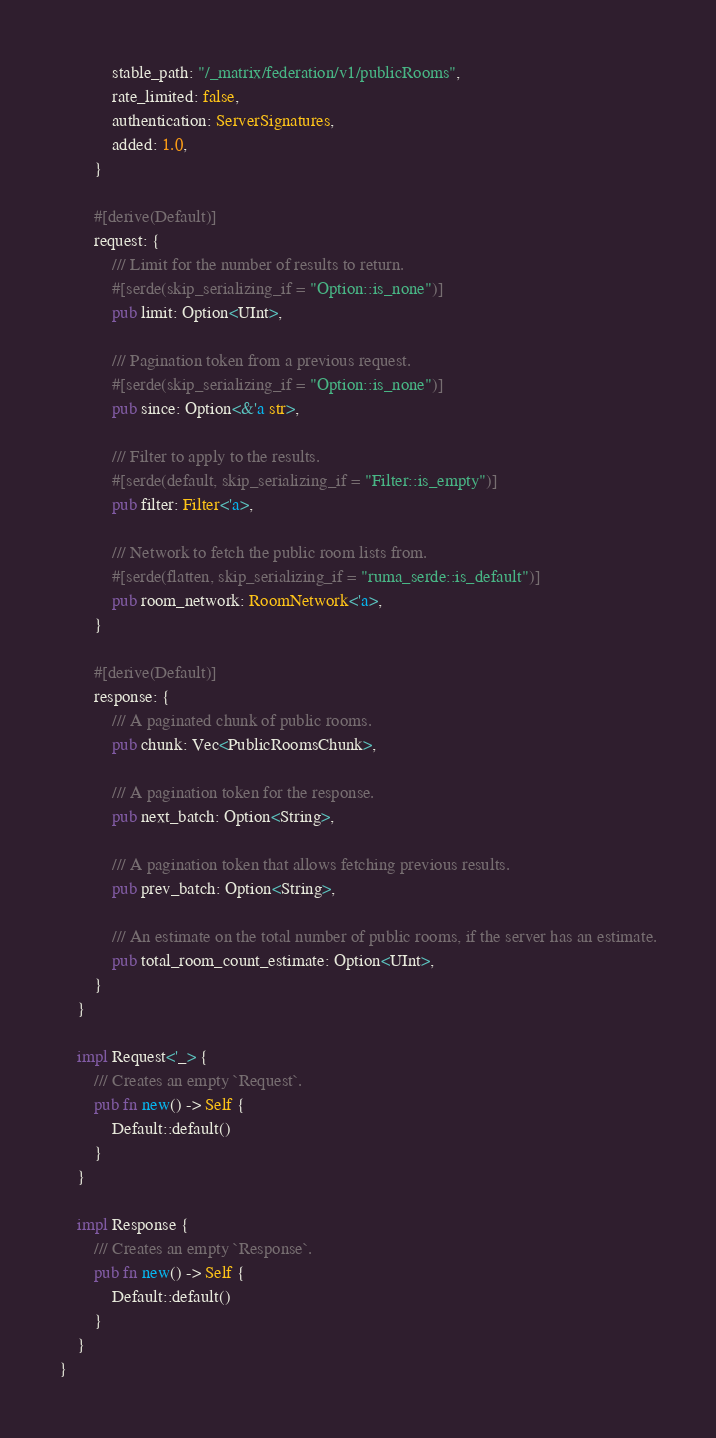<code> <loc_0><loc_0><loc_500><loc_500><_Rust_>            stable_path: "/_matrix/federation/v1/publicRooms",
            rate_limited: false,
            authentication: ServerSignatures,
            added: 1.0,
        }

        #[derive(Default)]
        request: {
            /// Limit for the number of results to return.
            #[serde(skip_serializing_if = "Option::is_none")]
            pub limit: Option<UInt>,

            /// Pagination token from a previous request.
            #[serde(skip_serializing_if = "Option::is_none")]
            pub since: Option<&'a str>,

            /// Filter to apply to the results.
            #[serde(default, skip_serializing_if = "Filter::is_empty")]
            pub filter: Filter<'a>,

            /// Network to fetch the public room lists from.
            #[serde(flatten, skip_serializing_if = "ruma_serde::is_default")]
            pub room_network: RoomNetwork<'a>,
        }

        #[derive(Default)]
        response: {
            /// A paginated chunk of public rooms.
            pub chunk: Vec<PublicRoomsChunk>,

            /// A pagination token for the response.
            pub next_batch: Option<String>,

            /// A pagination token that allows fetching previous results.
            pub prev_batch: Option<String>,

            /// An estimate on the total number of public rooms, if the server has an estimate.
            pub total_room_count_estimate: Option<UInt>,
        }
    }

    impl Request<'_> {
        /// Creates an empty `Request`.
        pub fn new() -> Self {
            Default::default()
        }
    }

    impl Response {
        /// Creates an empty `Response`.
        pub fn new() -> Self {
            Default::default()
        }
    }
}
</code> 